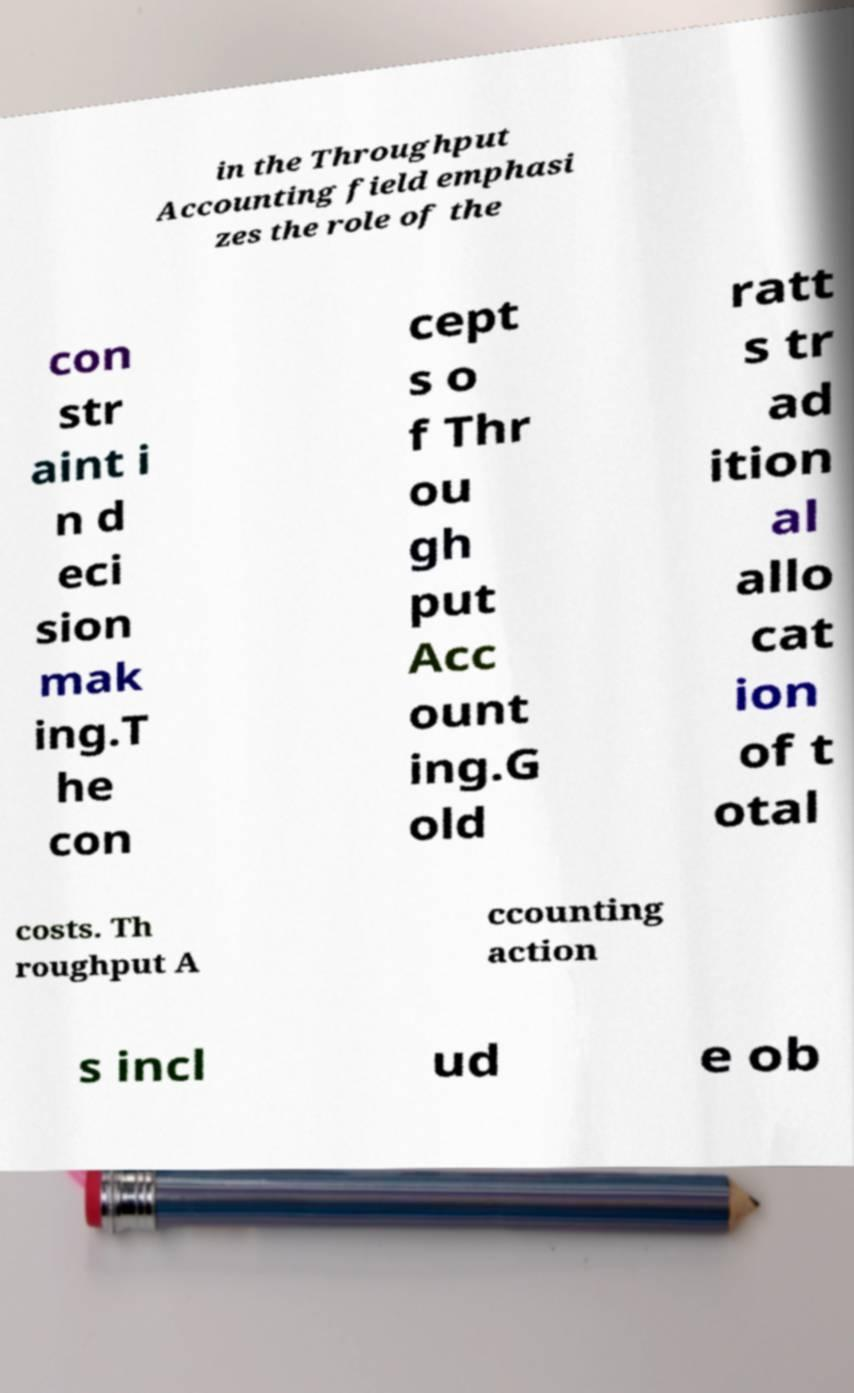Please read and relay the text visible in this image. What does it say? in the Throughput Accounting field emphasi zes the role of the con str aint i n d eci sion mak ing.T he con cept s o f Thr ou gh put Acc ount ing.G old ratt s tr ad ition al allo cat ion of t otal costs. Th roughput A ccounting action s incl ud e ob 